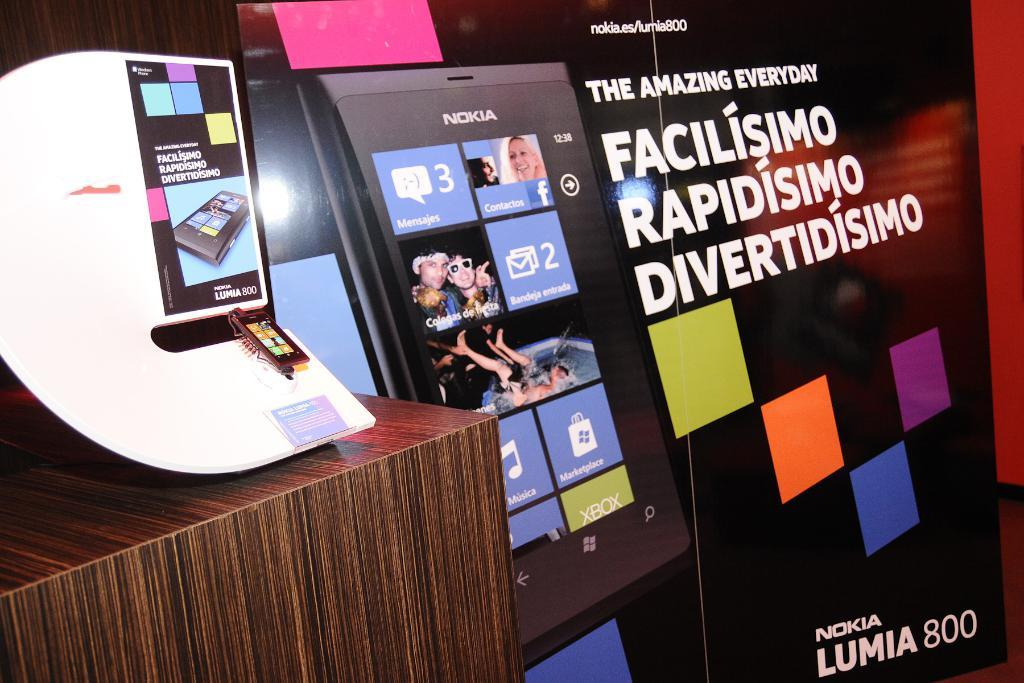What is the main subject in the center of the image? There are boards with text and images in the center of the image. What can be seen on the left side of the image? There is a table on the left side of the image. What type of bead is rolling on the table in the image? There is no bead present in the image. 